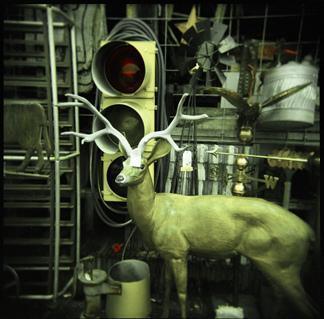How many deer are there?
Give a very brief answer. 1. 